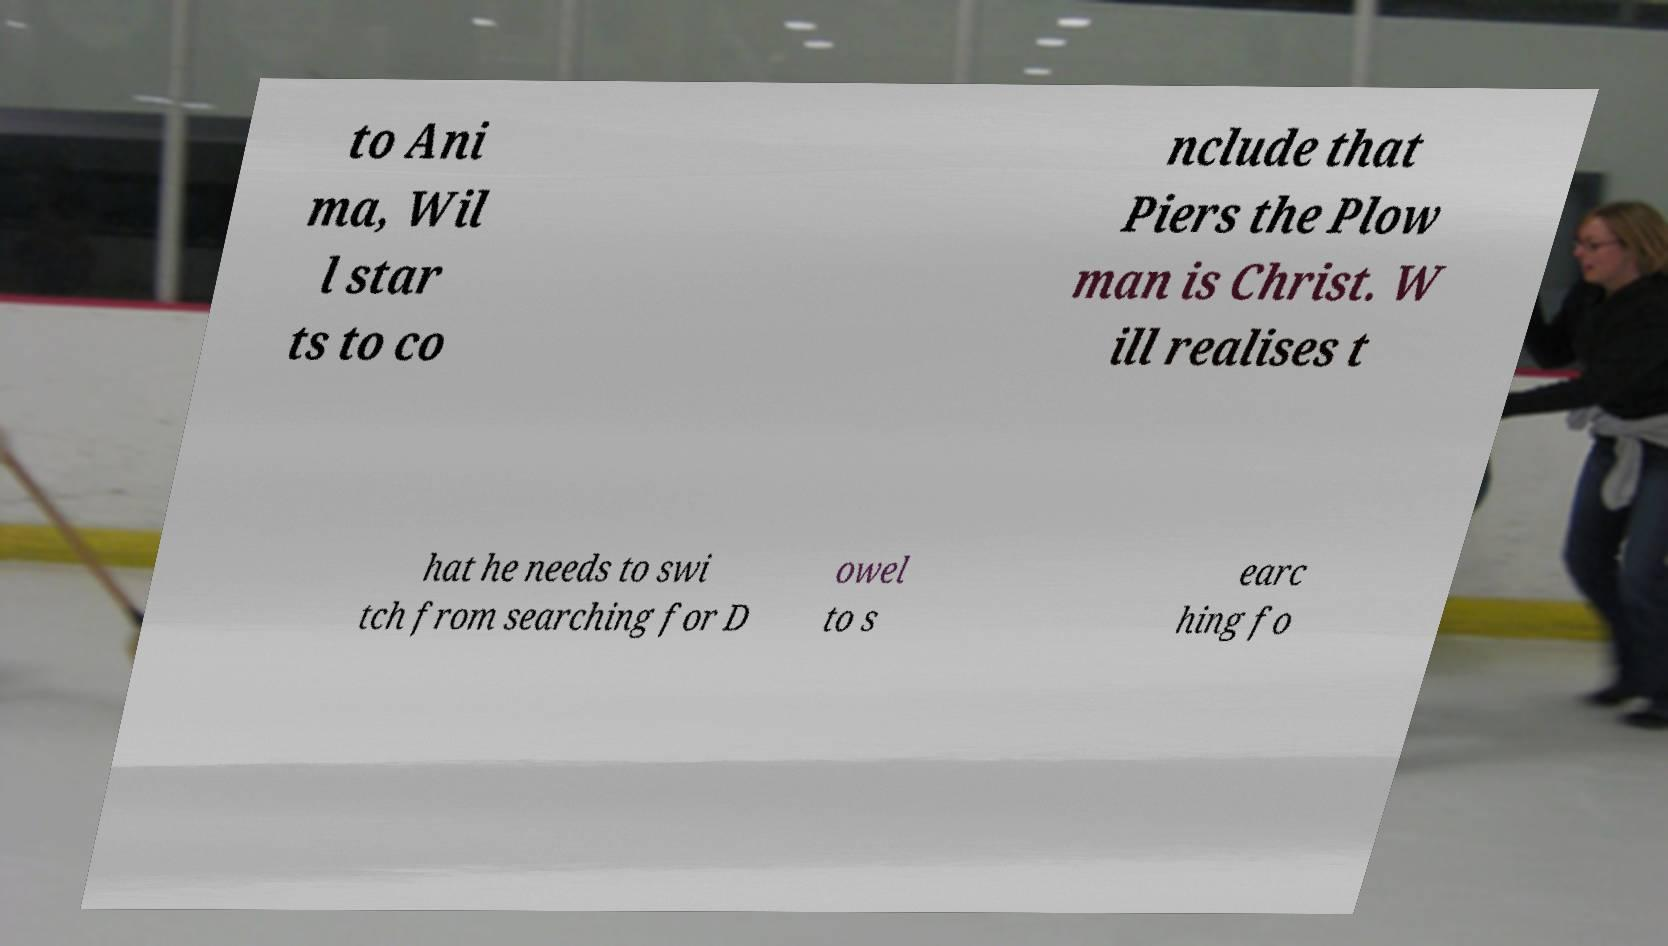Could you assist in decoding the text presented in this image and type it out clearly? to Ani ma, Wil l star ts to co nclude that Piers the Plow man is Christ. W ill realises t hat he needs to swi tch from searching for D owel to s earc hing fo 